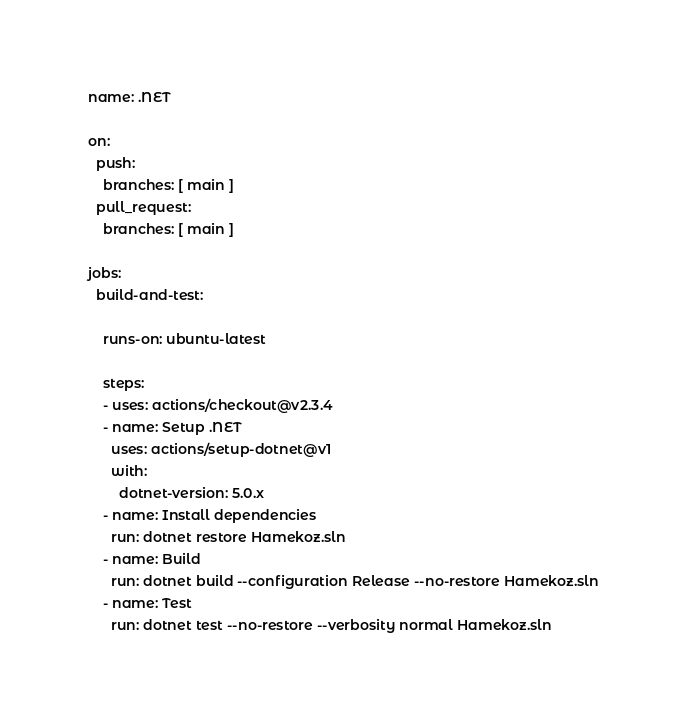Convert code to text. <code><loc_0><loc_0><loc_500><loc_500><_YAML_>name: .NET

on:
  push:
    branches: [ main ]
  pull_request:
    branches: [ main ]

jobs:
  build-and-test:

    runs-on: ubuntu-latest

    steps:
    - uses: actions/checkout@v2.3.4
    - name: Setup .NET
      uses: actions/setup-dotnet@v1
      with:
        dotnet-version: 5.0.x
    - name: Install dependencies
      run: dotnet restore Hamekoz.sln
    - name: Build
      run: dotnet build --configuration Release --no-restore Hamekoz.sln
    - name: Test
      run: dotnet test --no-restore --verbosity normal Hamekoz.sln
</code> 